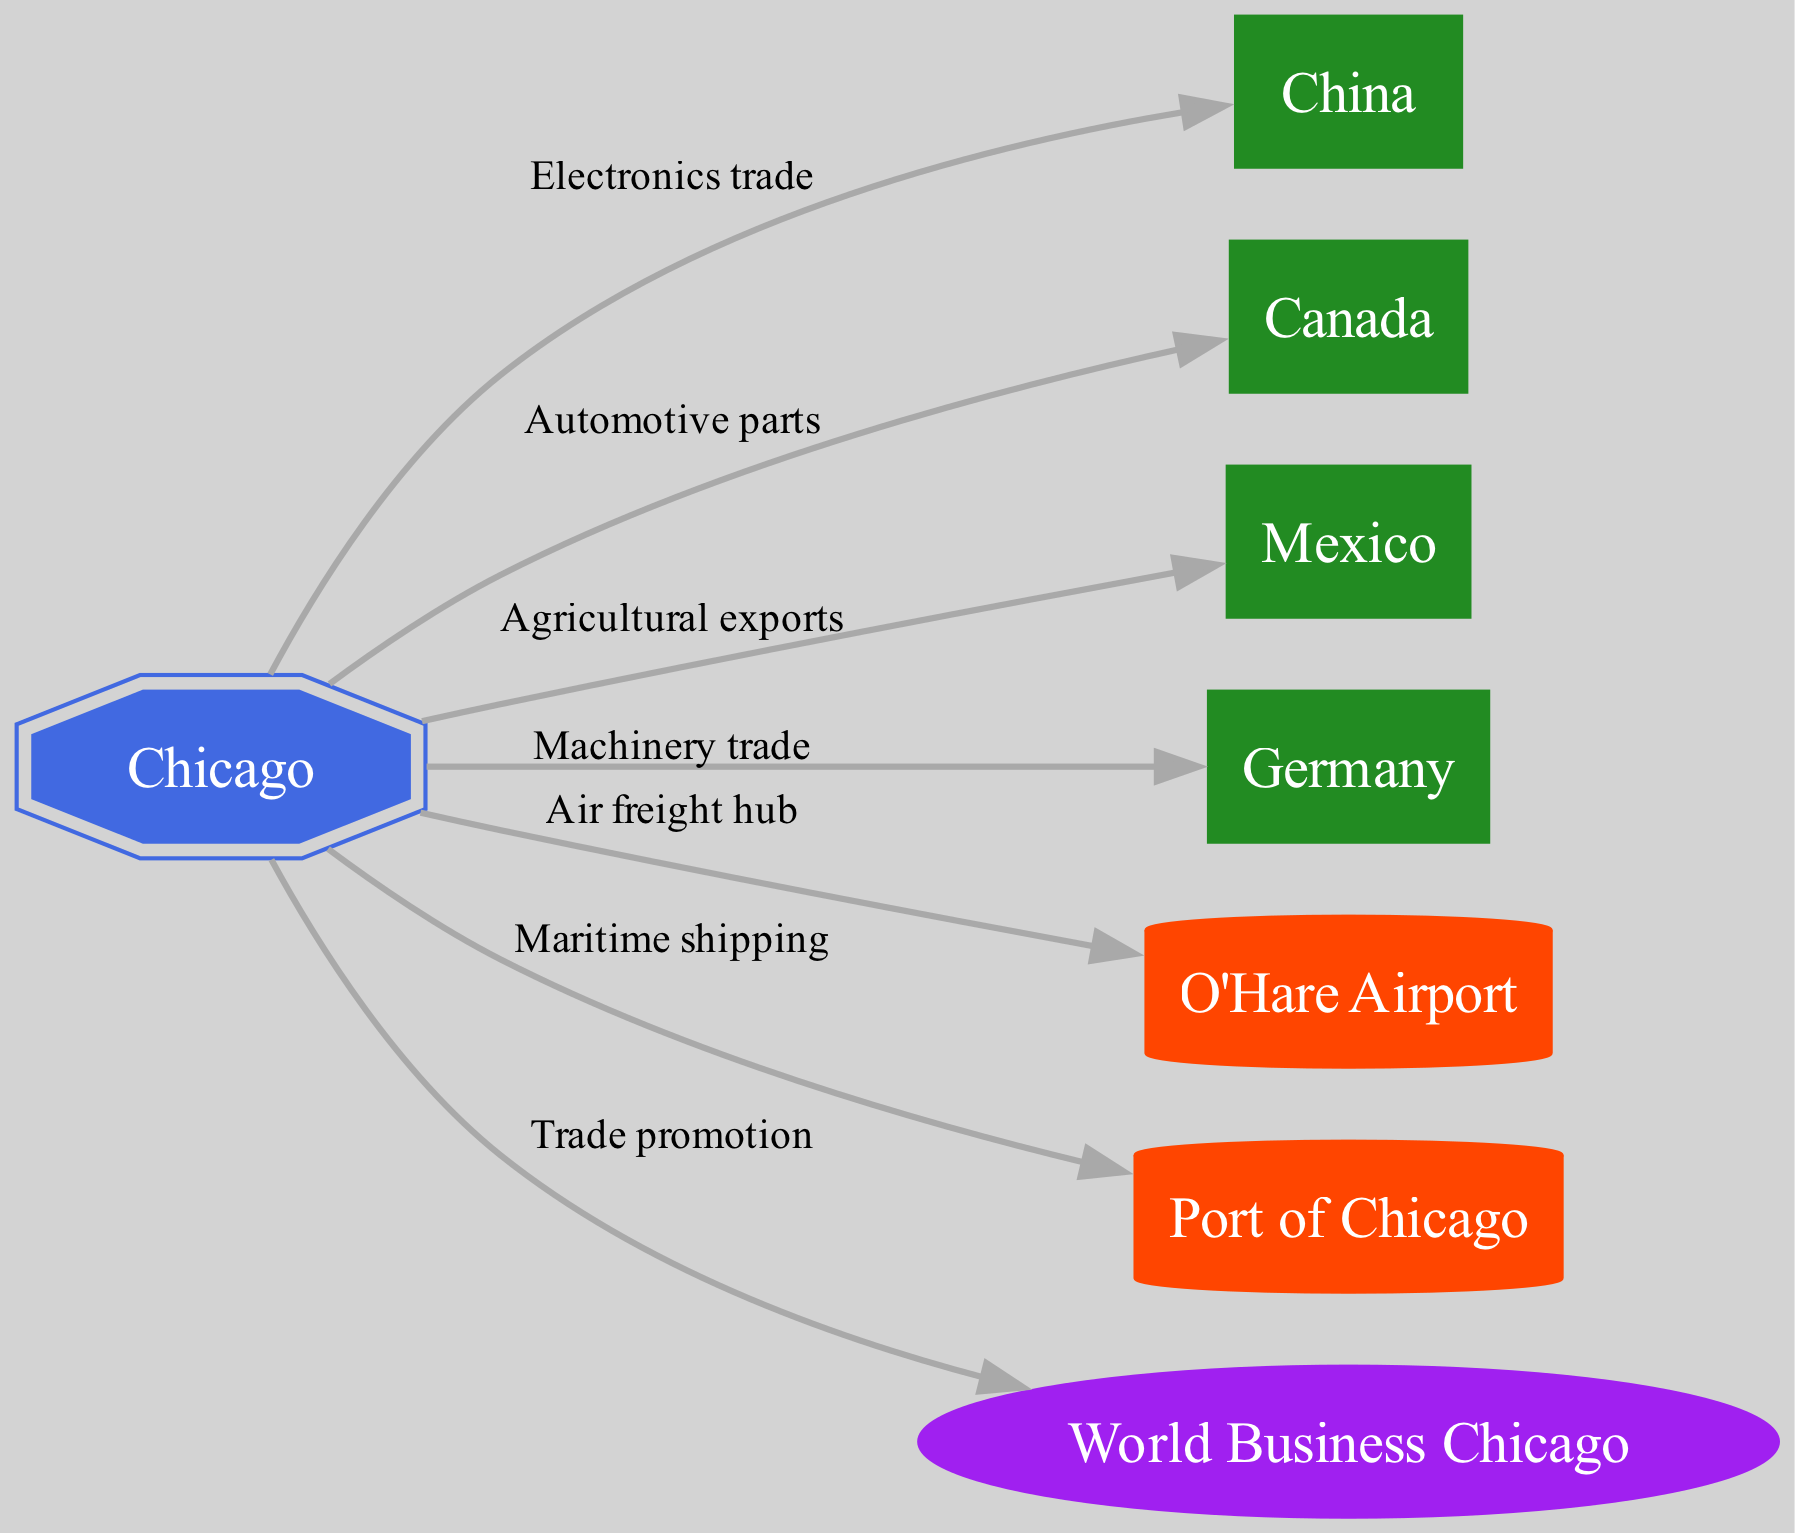What is the main trade industry between Chicago and China? The diagram indicates that the relationship between Chicago and China is characterized by "Electronics trade." This is found directly adjacent to the Chicago node and points to China with that specific label.
Answer: Electronics trade How many international trading partners are represented in the diagram? By counting the 'partner' nodes connected to Chicago, we find four partners: China, Canada, Mexico, and Germany. This is a matter of tallying the 'partner' nodes in the diagram.
Answer: 4 What type of node is the Port of Chicago? The Port of Chicago is categorized as an 'infrastructure' node in the diagram. This classification is clear based on its design and the color associated with that type.
Answer: Infrastructure Which city infrastructure serves as an air freight hub? The diagram shows that O'Hare Airport is designated as the "Air freight hub" connected directly to Chicago, indicating its role within the trading relationships.
Answer: O'Hare Airport What kind of products are imported from Canada to Chicago? The edge connecting Chicago to Canada is labeled as "Automotive parts," indicating the key product being imported from Canada into Chicago based on the diagram's information.
Answer: Automotive parts What organization is responsible for trade promotion in Chicago? The diagram shows that World Business Chicago is linked to Chicago with the label "Trade promotion," indicating its function in supporting trade in the region.
Answer: World Business Chicago What are the two modes of infrastructure supporting trade in Chicago? The diagram highlights two infrastructures related to trade: O'Hare Airport for air freight and the Port of Chicago for maritime shipping. By identifying these two linked nodes, we can conclude the modes of infrastructure.
Answer: O'Hare Airport and Port of Chicago Which partner is associated with agricultural exports to Chicago? According to the diagram, Mexico is connected to Chicago with the label "Agricultural exports," indicating it is the partner associated with this type of trade.
Answer: Mexico What is the label connecting Chicago to Germany? The relationship between Chicago and Germany is specified by the label "Machinery trade," which can be observed on the edge connecting these two nodes in the diagram.
Answer: Machinery trade 